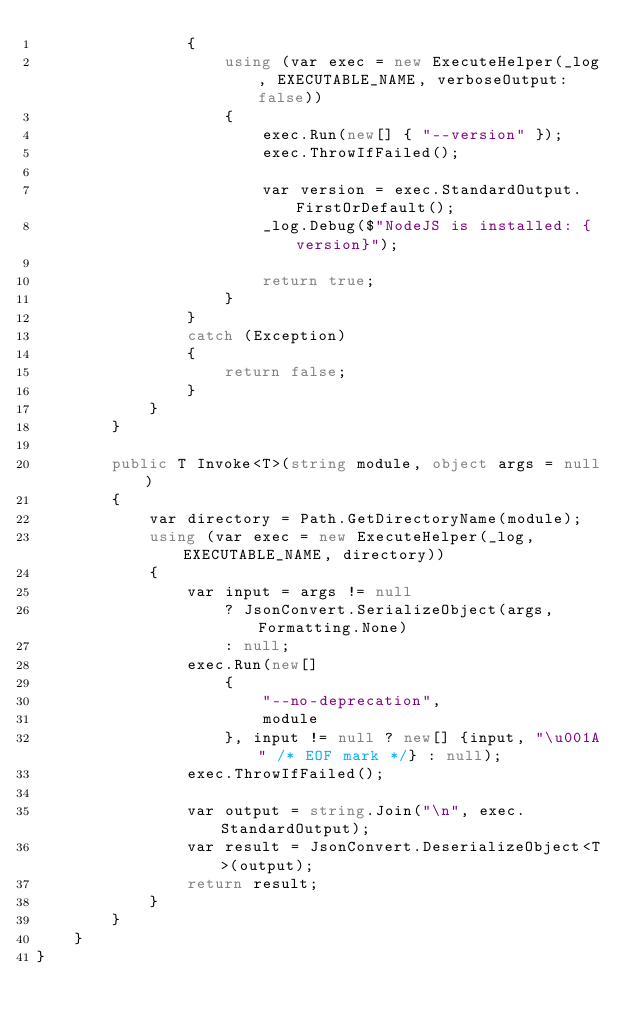<code> <loc_0><loc_0><loc_500><loc_500><_C#_>                {
                    using (var exec = new ExecuteHelper(_log, EXECUTABLE_NAME, verboseOutput: false))
                    {
                        exec.Run(new[] { "--version" });
                        exec.ThrowIfFailed();

                        var version = exec.StandardOutput.FirstOrDefault();
                        _log.Debug($"NodeJS is installed: {version}");

                        return true;
                    }
                }
                catch (Exception)
                {
                    return false;
                }
            }
        }

        public T Invoke<T>(string module, object args = null)
        {
            var directory = Path.GetDirectoryName(module);
            using (var exec = new ExecuteHelper(_log, EXECUTABLE_NAME, directory))
            {
                var input = args != null
                    ? JsonConvert.SerializeObject(args, Formatting.None)
                    : null;
                exec.Run(new[]
                    {
                        "--no-deprecation",
                        module
                    }, input != null ? new[] {input, "\u001A" /* EOF mark */} : null);
                exec.ThrowIfFailed();

                var output = string.Join("\n", exec.StandardOutput);
                var result = JsonConvert.DeserializeObject<T>(output);
                return result;
            }
        }
    }
}</code> 